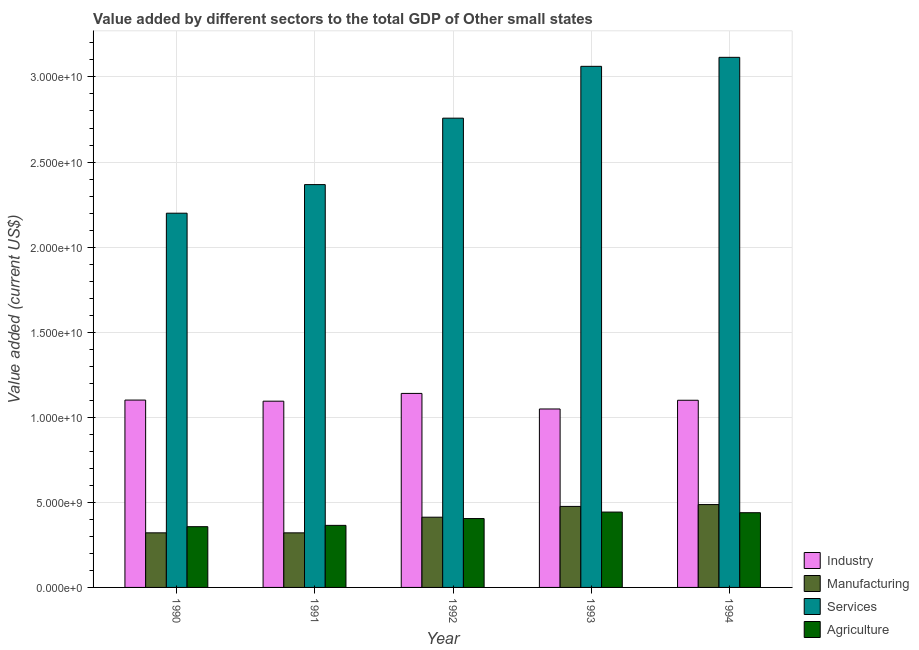How many different coloured bars are there?
Make the answer very short. 4. Are the number of bars on each tick of the X-axis equal?
Provide a succinct answer. Yes. How many bars are there on the 1st tick from the right?
Keep it short and to the point. 4. What is the label of the 4th group of bars from the left?
Provide a short and direct response. 1993. What is the value added by industrial sector in 1993?
Your answer should be compact. 1.05e+1. Across all years, what is the maximum value added by manufacturing sector?
Offer a very short reply. 4.87e+09. Across all years, what is the minimum value added by industrial sector?
Offer a terse response. 1.05e+1. In which year was the value added by industrial sector minimum?
Offer a very short reply. 1993. What is the total value added by agricultural sector in the graph?
Offer a terse response. 2.01e+1. What is the difference between the value added by agricultural sector in 1990 and that in 1991?
Your answer should be compact. -7.65e+07. What is the difference between the value added by services sector in 1992 and the value added by agricultural sector in 1993?
Ensure brevity in your answer.  -3.05e+09. What is the average value added by manufacturing sector per year?
Your answer should be compact. 4.03e+09. In the year 1993, what is the difference between the value added by manufacturing sector and value added by services sector?
Provide a short and direct response. 0. What is the ratio of the value added by agricultural sector in 1993 to that in 1994?
Ensure brevity in your answer.  1.01. Is the difference between the value added by agricultural sector in 1990 and 1991 greater than the difference between the value added by industrial sector in 1990 and 1991?
Offer a terse response. No. What is the difference between the highest and the second highest value added by services sector?
Provide a succinct answer. 5.29e+08. What is the difference between the highest and the lowest value added by agricultural sector?
Give a very brief answer. 8.58e+08. In how many years, is the value added by industrial sector greater than the average value added by industrial sector taken over all years?
Make the answer very short. 3. Is the sum of the value added by agricultural sector in 1990 and 1993 greater than the maximum value added by manufacturing sector across all years?
Keep it short and to the point. Yes. Is it the case that in every year, the sum of the value added by manufacturing sector and value added by agricultural sector is greater than the sum of value added by industrial sector and value added by services sector?
Your answer should be very brief. No. What does the 4th bar from the left in 1990 represents?
Keep it short and to the point. Agriculture. What does the 1st bar from the right in 1994 represents?
Make the answer very short. Agriculture. Are all the bars in the graph horizontal?
Make the answer very short. No. How are the legend labels stacked?
Your answer should be compact. Vertical. What is the title of the graph?
Your answer should be compact. Value added by different sectors to the total GDP of Other small states. What is the label or title of the Y-axis?
Make the answer very short. Value added (current US$). What is the Value added (current US$) of Industry in 1990?
Your response must be concise. 1.10e+1. What is the Value added (current US$) in Manufacturing in 1990?
Give a very brief answer. 3.21e+09. What is the Value added (current US$) of Services in 1990?
Ensure brevity in your answer.  2.20e+1. What is the Value added (current US$) in Agriculture in 1990?
Your answer should be very brief. 3.57e+09. What is the Value added (current US$) of Industry in 1991?
Provide a succinct answer. 1.09e+1. What is the Value added (current US$) of Manufacturing in 1991?
Offer a terse response. 3.21e+09. What is the Value added (current US$) in Services in 1991?
Ensure brevity in your answer.  2.37e+1. What is the Value added (current US$) in Agriculture in 1991?
Your answer should be compact. 3.65e+09. What is the Value added (current US$) in Industry in 1992?
Your response must be concise. 1.14e+1. What is the Value added (current US$) of Manufacturing in 1992?
Keep it short and to the point. 4.13e+09. What is the Value added (current US$) in Services in 1992?
Your answer should be very brief. 2.76e+1. What is the Value added (current US$) of Agriculture in 1992?
Provide a short and direct response. 4.05e+09. What is the Value added (current US$) of Industry in 1993?
Your answer should be compact. 1.05e+1. What is the Value added (current US$) of Manufacturing in 1993?
Provide a short and direct response. 4.76e+09. What is the Value added (current US$) of Services in 1993?
Ensure brevity in your answer.  3.06e+1. What is the Value added (current US$) in Agriculture in 1993?
Your answer should be very brief. 4.43e+09. What is the Value added (current US$) in Industry in 1994?
Make the answer very short. 1.10e+1. What is the Value added (current US$) in Manufacturing in 1994?
Keep it short and to the point. 4.87e+09. What is the Value added (current US$) in Services in 1994?
Your answer should be compact. 3.12e+1. What is the Value added (current US$) in Agriculture in 1994?
Give a very brief answer. 4.39e+09. Across all years, what is the maximum Value added (current US$) of Industry?
Your answer should be compact. 1.14e+1. Across all years, what is the maximum Value added (current US$) of Manufacturing?
Keep it short and to the point. 4.87e+09. Across all years, what is the maximum Value added (current US$) in Services?
Your answer should be very brief. 3.12e+1. Across all years, what is the maximum Value added (current US$) in Agriculture?
Keep it short and to the point. 4.43e+09. Across all years, what is the minimum Value added (current US$) of Industry?
Keep it short and to the point. 1.05e+1. Across all years, what is the minimum Value added (current US$) in Manufacturing?
Give a very brief answer. 3.21e+09. Across all years, what is the minimum Value added (current US$) of Services?
Offer a very short reply. 2.20e+1. Across all years, what is the minimum Value added (current US$) of Agriculture?
Give a very brief answer. 3.57e+09. What is the total Value added (current US$) of Industry in the graph?
Offer a very short reply. 5.48e+1. What is the total Value added (current US$) in Manufacturing in the graph?
Offer a very short reply. 2.02e+1. What is the total Value added (current US$) in Services in the graph?
Give a very brief answer. 1.35e+11. What is the total Value added (current US$) of Agriculture in the graph?
Keep it short and to the point. 2.01e+1. What is the difference between the Value added (current US$) in Industry in 1990 and that in 1991?
Give a very brief answer. 6.57e+07. What is the difference between the Value added (current US$) of Manufacturing in 1990 and that in 1991?
Offer a very short reply. 3.41e+05. What is the difference between the Value added (current US$) of Services in 1990 and that in 1991?
Provide a short and direct response. -1.68e+09. What is the difference between the Value added (current US$) of Agriculture in 1990 and that in 1991?
Ensure brevity in your answer.  -7.65e+07. What is the difference between the Value added (current US$) of Industry in 1990 and that in 1992?
Your response must be concise. -3.91e+08. What is the difference between the Value added (current US$) of Manufacturing in 1990 and that in 1992?
Your answer should be very brief. -9.19e+08. What is the difference between the Value added (current US$) of Services in 1990 and that in 1992?
Your answer should be compact. -5.58e+09. What is the difference between the Value added (current US$) of Agriculture in 1990 and that in 1992?
Ensure brevity in your answer.  -4.77e+08. What is the difference between the Value added (current US$) in Industry in 1990 and that in 1993?
Make the answer very short. 5.24e+08. What is the difference between the Value added (current US$) of Manufacturing in 1990 and that in 1993?
Ensure brevity in your answer.  -1.55e+09. What is the difference between the Value added (current US$) in Services in 1990 and that in 1993?
Give a very brief answer. -8.63e+09. What is the difference between the Value added (current US$) of Agriculture in 1990 and that in 1993?
Offer a very short reply. -8.58e+08. What is the difference between the Value added (current US$) in Industry in 1990 and that in 1994?
Make the answer very short. 1.17e+07. What is the difference between the Value added (current US$) in Manufacturing in 1990 and that in 1994?
Your answer should be very brief. -1.66e+09. What is the difference between the Value added (current US$) in Services in 1990 and that in 1994?
Your answer should be compact. -9.16e+09. What is the difference between the Value added (current US$) of Agriculture in 1990 and that in 1994?
Offer a terse response. -8.20e+08. What is the difference between the Value added (current US$) of Industry in 1991 and that in 1992?
Offer a very short reply. -4.57e+08. What is the difference between the Value added (current US$) in Manufacturing in 1991 and that in 1992?
Offer a very short reply. -9.19e+08. What is the difference between the Value added (current US$) in Services in 1991 and that in 1992?
Your answer should be very brief. -3.90e+09. What is the difference between the Value added (current US$) of Agriculture in 1991 and that in 1992?
Your response must be concise. -4.00e+08. What is the difference between the Value added (current US$) in Industry in 1991 and that in 1993?
Your answer should be very brief. 4.58e+08. What is the difference between the Value added (current US$) in Manufacturing in 1991 and that in 1993?
Provide a short and direct response. -1.55e+09. What is the difference between the Value added (current US$) of Services in 1991 and that in 1993?
Ensure brevity in your answer.  -6.95e+09. What is the difference between the Value added (current US$) of Agriculture in 1991 and that in 1993?
Your response must be concise. -7.81e+08. What is the difference between the Value added (current US$) of Industry in 1991 and that in 1994?
Keep it short and to the point. -5.40e+07. What is the difference between the Value added (current US$) in Manufacturing in 1991 and that in 1994?
Make the answer very short. -1.66e+09. What is the difference between the Value added (current US$) in Services in 1991 and that in 1994?
Your response must be concise. -7.48e+09. What is the difference between the Value added (current US$) of Agriculture in 1991 and that in 1994?
Give a very brief answer. -7.44e+08. What is the difference between the Value added (current US$) in Industry in 1992 and that in 1993?
Ensure brevity in your answer.  9.15e+08. What is the difference between the Value added (current US$) in Manufacturing in 1992 and that in 1993?
Your response must be concise. -6.34e+08. What is the difference between the Value added (current US$) in Services in 1992 and that in 1993?
Your response must be concise. -3.05e+09. What is the difference between the Value added (current US$) in Agriculture in 1992 and that in 1993?
Offer a terse response. -3.81e+08. What is the difference between the Value added (current US$) of Industry in 1992 and that in 1994?
Give a very brief answer. 4.03e+08. What is the difference between the Value added (current US$) in Manufacturing in 1992 and that in 1994?
Ensure brevity in your answer.  -7.43e+08. What is the difference between the Value added (current US$) of Services in 1992 and that in 1994?
Ensure brevity in your answer.  -3.58e+09. What is the difference between the Value added (current US$) of Agriculture in 1992 and that in 1994?
Make the answer very short. -3.44e+08. What is the difference between the Value added (current US$) of Industry in 1993 and that in 1994?
Offer a terse response. -5.12e+08. What is the difference between the Value added (current US$) in Manufacturing in 1993 and that in 1994?
Your answer should be compact. -1.09e+08. What is the difference between the Value added (current US$) of Services in 1993 and that in 1994?
Your response must be concise. -5.29e+08. What is the difference between the Value added (current US$) in Agriculture in 1993 and that in 1994?
Provide a succinct answer. 3.76e+07. What is the difference between the Value added (current US$) in Industry in 1990 and the Value added (current US$) in Manufacturing in 1991?
Your answer should be compact. 7.80e+09. What is the difference between the Value added (current US$) in Industry in 1990 and the Value added (current US$) in Services in 1991?
Keep it short and to the point. -1.27e+1. What is the difference between the Value added (current US$) of Industry in 1990 and the Value added (current US$) of Agriculture in 1991?
Your answer should be compact. 7.36e+09. What is the difference between the Value added (current US$) of Manufacturing in 1990 and the Value added (current US$) of Services in 1991?
Offer a terse response. -2.05e+1. What is the difference between the Value added (current US$) in Manufacturing in 1990 and the Value added (current US$) in Agriculture in 1991?
Keep it short and to the point. -4.39e+08. What is the difference between the Value added (current US$) of Services in 1990 and the Value added (current US$) of Agriculture in 1991?
Your response must be concise. 1.83e+1. What is the difference between the Value added (current US$) in Industry in 1990 and the Value added (current US$) in Manufacturing in 1992?
Give a very brief answer. 6.88e+09. What is the difference between the Value added (current US$) of Industry in 1990 and the Value added (current US$) of Services in 1992?
Provide a succinct answer. -1.66e+1. What is the difference between the Value added (current US$) of Industry in 1990 and the Value added (current US$) of Agriculture in 1992?
Make the answer very short. 6.96e+09. What is the difference between the Value added (current US$) of Manufacturing in 1990 and the Value added (current US$) of Services in 1992?
Provide a succinct answer. -2.44e+1. What is the difference between the Value added (current US$) in Manufacturing in 1990 and the Value added (current US$) in Agriculture in 1992?
Make the answer very short. -8.39e+08. What is the difference between the Value added (current US$) of Services in 1990 and the Value added (current US$) of Agriculture in 1992?
Offer a terse response. 1.79e+1. What is the difference between the Value added (current US$) of Industry in 1990 and the Value added (current US$) of Manufacturing in 1993?
Your response must be concise. 6.25e+09. What is the difference between the Value added (current US$) of Industry in 1990 and the Value added (current US$) of Services in 1993?
Keep it short and to the point. -1.96e+1. What is the difference between the Value added (current US$) of Industry in 1990 and the Value added (current US$) of Agriculture in 1993?
Provide a succinct answer. 6.58e+09. What is the difference between the Value added (current US$) of Manufacturing in 1990 and the Value added (current US$) of Services in 1993?
Provide a succinct answer. -2.74e+1. What is the difference between the Value added (current US$) of Manufacturing in 1990 and the Value added (current US$) of Agriculture in 1993?
Your response must be concise. -1.22e+09. What is the difference between the Value added (current US$) in Services in 1990 and the Value added (current US$) in Agriculture in 1993?
Keep it short and to the point. 1.76e+1. What is the difference between the Value added (current US$) in Industry in 1990 and the Value added (current US$) in Manufacturing in 1994?
Your response must be concise. 6.14e+09. What is the difference between the Value added (current US$) of Industry in 1990 and the Value added (current US$) of Services in 1994?
Offer a terse response. -2.01e+1. What is the difference between the Value added (current US$) in Industry in 1990 and the Value added (current US$) in Agriculture in 1994?
Provide a short and direct response. 6.62e+09. What is the difference between the Value added (current US$) of Manufacturing in 1990 and the Value added (current US$) of Services in 1994?
Provide a short and direct response. -2.79e+1. What is the difference between the Value added (current US$) in Manufacturing in 1990 and the Value added (current US$) in Agriculture in 1994?
Keep it short and to the point. -1.18e+09. What is the difference between the Value added (current US$) of Services in 1990 and the Value added (current US$) of Agriculture in 1994?
Your response must be concise. 1.76e+1. What is the difference between the Value added (current US$) in Industry in 1991 and the Value added (current US$) in Manufacturing in 1992?
Give a very brief answer. 6.82e+09. What is the difference between the Value added (current US$) of Industry in 1991 and the Value added (current US$) of Services in 1992?
Offer a very short reply. -1.66e+1. What is the difference between the Value added (current US$) of Industry in 1991 and the Value added (current US$) of Agriculture in 1992?
Give a very brief answer. 6.90e+09. What is the difference between the Value added (current US$) of Manufacturing in 1991 and the Value added (current US$) of Services in 1992?
Give a very brief answer. -2.44e+1. What is the difference between the Value added (current US$) in Manufacturing in 1991 and the Value added (current US$) in Agriculture in 1992?
Your answer should be very brief. -8.39e+08. What is the difference between the Value added (current US$) in Services in 1991 and the Value added (current US$) in Agriculture in 1992?
Ensure brevity in your answer.  1.96e+1. What is the difference between the Value added (current US$) in Industry in 1991 and the Value added (current US$) in Manufacturing in 1993?
Your response must be concise. 6.18e+09. What is the difference between the Value added (current US$) in Industry in 1991 and the Value added (current US$) in Services in 1993?
Make the answer very short. -1.97e+1. What is the difference between the Value added (current US$) of Industry in 1991 and the Value added (current US$) of Agriculture in 1993?
Provide a short and direct response. 6.52e+09. What is the difference between the Value added (current US$) of Manufacturing in 1991 and the Value added (current US$) of Services in 1993?
Ensure brevity in your answer.  -2.74e+1. What is the difference between the Value added (current US$) in Manufacturing in 1991 and the Value added (current US$) in Agriculture in 1993?
Your answer should be very brief. -1.22e+09. What is the difference between the Value added (current US$) of Services in 1991 and the Value added (current US$) of Agriculture in 1993?
Your answer should be compact. 1.92e+1. What is the difference between the Value added (current US$) of Industry in 1991 and the Value added (current US$) of Manufacturing in 1994?
Provide a succinct answer. 6.08e+09. What is the difference between the Value added (current US$) of Industry in 1991 and the Value added (current US$) of Services in 1994?
Ensure brevity in your answer.  -2.02e+1. What is the difference between the Value added (current US$) in Industry in 1991 and the Value added (current US$) in Agriculture in 1994?
Your answer should be very brief. 6.55e+09. What is the difference between the Value added (current US$) in Manufacturing in 1991 and the Value added (current US$) in Services in 1994?
Offer a very short reply. -2.79e+1. What is the difference between the Value added (current US$) of Manufacturing in 1991 and the Value added (current US$) of Agriculture in 1994?
Your response must be concise. -1.18e+09. What is the difference between the Value added (current US$) of Services in 1991 and the Value added (current US$) of Agriculture in 1994?
Provide a succinct answer. 1.93e+1. What is the difference between the Value added (current US$) in Industry in 1992 and the Value added (current US$) in Manufacturing in 1993?
Your response must be concise. 6.64e+09. What is the difference between the Value added (current US$) in Industry in 1992 and the Value added (current US$) in Services in 1993?
Make the answer very short. -1.92e+1. What is the difference between the Value added (current US$) of Industry in 1992 and the Value added (current US$) of Agriculture in 1993?
Your answer should be very brief. 6.97e+09. What is the difference between the Value added (current US$) of Manufacturing in 1992 and the Value added (current US$) of Services in 1993?
Provide a short and direct response. -2.65e+1. What is the difference between the Value added (current US$) in Manufacturing in 1992 and the Value added (current US$) in Agriculture in 1993?
Offer a very short reply. -3.01e+08. What is the difference between the Value added (current US$) of Services in 1992 and the Value added (current US$) of Agriculture in 1993?
Your answer should be compact. 2.31e+1. What is the difference between the Value added (current US$) of Industry in 1992 and the Value added (current US$) of Manufacturing in 1994?
Make the answer very short. 6.53e+09. What is the difference between the Value added (current US$) in Industry in 1992 and the Value added (current US$) in Services in 1994?
Give a very brief answer. -1.98e+1. What is the difference between the Value added (current US$) in Industry in 1992 and the Value added (current US$) in Agriculture in 1994?
Offer a very short reply. 7.01e+09. What is the difference between the Value added (current US$) of Manufacturing in 1992 and the Value added (current US$) of Services in 1994?
Your response must be concise. -2.70e+1. What is the difference between the Value added (current US$) of Manufacturing in 1992 and the Value added (current US$) of Agriculture in 1994?
Your answer should be compact. -2.64e+08. What is the difference between the Value added (current US$) in Services in 1992 and the Value added (current US$) in Agriculture in 1994?
Give a very brief answer. 2.32e+1. What is the difference between the Value added (current US$) of Industry in 1993 and the Value added (current US$) of Manufacturing in 1994?
Provide a short and direct response. 5.62e+09. What is the difference between the Value added (current US$) of Industry in 1993 and the Value added (current US$) of Services in 1994?
Ensure brevity in your answer.  -2.07e+1. What is the difference between the Value added (current US$) in Industry in 1993 and the Value added (current US$) in Agriculture in 1994?
Your response must be concise. 6.10e+09. What is the difference between the Value added (current US$) of Manufacturing in 1993 and the Value added (current US$) of Services in 1994?
Make the answer very short. -2.64e+1. What is the difference between the Value added (current US$) in Manufacturing in 1993 and the Value added (current US$) in Agriculture in 1994?
Keep it short and to the point. 3.70e+08. What is the difference between the Value added (current US$) of Services in 1993 and the Value added (current US$) of Agriculture in 1994?
Give a very brief answer. 2.62e+1. What is the average Value added (current US$) of Industry per year?
Offer a terse response. 1.10e+1. What is the average Value added (current US$) of Manufacturing per year?
Your response must be concise. 4.03e+09. What is the average Value added (current US$) in Services per year?
Give a very brief answer. 2.70e+1. What is the average Value added (current US$) of Agriculture per year?
Provide a succinct answer. 4.02e+09. In the year 1990, what is the difference between the Value added (current US$) of Industry and Value added (current US$) of Manufacturing?
Your answer should be very brief. 7.80e+09. In the year 1990, what is the difference between the Value added (current US$) in Industry and Value added (current US$) in Services?
Provide a succinct answer. -1.10e+1. In the year 1990, what is the difference between the Value added (current US$) of Industry and Value added (current US$) of Agriculture?
Provide a short and direct response. 7.44e+09. In the year 1990, what is the difference between the Value added (current US$) of Manufacturing and Value added (current US$) of Services?
Provide a succinct answer. -1.88e+1. In the year 1990, what is the difference between the Value added (current US$) in Manufacturing and Value added (current US$) in Agriculture?
Your response must be concise. -3.62e+08. In the year 1990, what is the difference between the Value added (current US$) in Services and Value added (current US$) in Agriculture?
Keep it short and to the point. 1.84e+1. In the year 1991, what is the difference between the Value added (current US$) of Industry and Value added (current US$) of Manufacturing?
Offer a terse response. 7.74e+09. In the year 1991, what is the difference between the Value added (current US$) in Industry and Value added (current US$) in Services?
Ensure brevity in your answer.  -1.27e+1. In the year 1991, what is the difference between the Value added (current US$) in Industry and Value added (current US$) in Agriculture?
Provide a short and direct response. 7.30e+09. In the year 1991, what is the difference between the Value added (current US$) of Manufacturing and Value added (current US$) of Services?
Provide a succinct answer. -2.05e+1. In the year 1991, what is the difference between the Value added (current US$) in Manufacturing and Value added (current US$) in Agriculture?
Provide a short and direct response. -4.39e+08. In the year 1991, what is the difference between the Value added (current US$) in Services and Value added (current US$) in Agriculture?
Offer a very short reply. 2.00e+1. In the year 1992, what is the difference between the Value added (current US$) in Industry and Value added (current US$) in Manufacturing?
Keep it short and to the point. 7.28e+09. In the year 1992, what is the difference between the Value added (current US$) in Industry and Value added (current US$) in Services?
Give a very brief answer. -1.62e+1. In the year 1992, what is the difference between the Value added (current US$) of Industry and Value added (current US$) of Agriculture?
Offer a terse response. 7.36e+09. In the year 1992, what is the difference between the Value added (current US$) of Manufacturing and Value added (current US$) of Services?
Your answer should be compact. -2.35e+1. In the year 1992, what is the difference between the Value added (current US$) of Manufacturing and Value added (current US$) of Agriculture?
Offer a very short reply. 7.99e+07. In the year 1992, what is the difference between the Value added (current US$) of Services and Value added (current US$) of Agriculture?
Give a very brief answer. 2.35e+1. In the year 1993, what is the difference between the Value added (current US$) of Industry and Value added (current US$) of Manufacturing?
Make the answer very short. 5.73e+09. In the year 1993, what is the difference between the Value added (current US$) of Industry and Value added (current US$) of Services?
Give a very brief answer. -2.01e+1. In the year 1993, what is the difference between the Value added (current US$) in Industry and Value added (current US$) in Agriculture?
Provide a short and direct response. 6.06e+09. In the year 1993, what is the difference between the Value added (current US$) of Manufacturing and Value added (current US$) of Services?
Make the answer very short. -2.59e+1. In the year 1993, what is the difference between the Value added (current US$) in Manufacturing and Value added (current US$) in Agriculture?
Offer a terse response. 3.33e+08. In the year 1993, what is the difference between the Value added (current US$) of Services and Value added (current US$) of Agriculture?
Your answer should be compact. 2.62e+1. In the year 1994, what is the difference between the Value added (current US$) in Industry and Value added (current US$) in Manufacturing?
Offer a very short reply. 6.13e+09. In the year 1994, what is the difference between the Value added (current US$) in Industry and Value added (current US$) in Services?
Keep it short and to the point. -2.02e+1. In the year 1994, what is the difference between the Value added (current US$) of Industry and Value added (current US$) of Agriculture?
Ensure brevity in your answer.  6.61e+09. In the year 1994, what is the difference between the Value added (current US$) in Manufacturing and Value added (current US$) in Services?
Your answer should be compact. -2.63e+1. In the year 1994, what is the difference between the Value added (current US$) in Manufacturing and Value added (current US$) in Agriculture?
Offer a very short reply. 4.79e+08. In the year 1994, what is the difference between the Value added (current US$) of Services and Value added (current US$) of Agriculture?
Offer a very short reply. 2.68e+1. What is the ratio of the Value added (current US$) of Industry in 1990 to that in 1991?
Offer a terse response. 1.01. What is the ratio of the Value added (current US$) in Services in 1990 to that in 1991?
Ensure brevity in your answer.  0.93. What is the ratio of the Value added (current US$) in Industry in 1990 to that in 1992?
Provide a short and direct response. 0.97. What is the ratio of the Value added (current US$) in Manufacturing in 1990 to that in 1992?
Provide a succinct answer. 0.78. What is the ratio of the Value added (current US$) of Services in 1990 to that in 1992?
Keep it short and to the point. 0.8. What is the ratio of the Value added (current US$) of Agriculture in 1990 to that in 1992?
Provide a succinct answer. 0.88. What is the ratio of the Value added (current US$) in Industry in 1990 to that in 1993?
Offer a terse response. 1.05. What is the ratio of the Value added (current US$) in Manufacturing in 1990 to that in 1993?
Offer a terse response. 0.67. What is the ratio of the Value added (current US$) in Services in 1990 to that in 1993?
Make the answer very short. 0.72. What is the ratio of the Value added (current US$) in Agriculture in 1990 to that in 1993?
Your answer should be very brief. 0.81. What is the ratio of the Value added (current US$) of Manufacturing in 1990 to that in 1994?
Offer a terse response. 0.66. What is the ratio of the Value added (current US$) of Services in 1990 to that in 1994?
Your answer should be compact. 0.71. What is the ratio of the Value added (current US$) in Agriculture in 1990 to that in 1994?
Provide a short and direct response. 0.81. What is the ratio of the Value added (current US$) in Industry in 1991 to that in 1992?
Your answer should be compact. 0.96. What is the ratio of the Value added (current US$) in Manufacturing in 1991 to that in 1992?
Your response must be concise. 0.78. What is the ratio of the Value added (current US$) in Services in 1991 to that in 1992?
Your answer should be compact. 0.86. What is the ratio of the Value added (current US$) of Agriculture in 1991 to that in 1992?
Ensure brevity in your answer.  0.9. What is the ratio of the Value added (current US$) in Industry in 1991 to that in 1993?
Make the answer very short. 1.04. What is the ratio of the Value added (current US$) of Manufacturing in 1991 to that in 1993?
Your answer should be very brief. 0.67. What is the ratio of the Value added (current US$) of Services in 1991 to that in 1993?
Provide a succinct answer. 0.77. What is the ratio of the Value added (current US$) in Agriculture in 1991 to that in 1993?
Your response must be concise. 0.82. What is the ratio of the Value added (current US$) of Industry in 1991 to that in 1994?
Offer a terse response. 1. What is the ratio of the Value added (current US$) in Manufacturing in 1991 to that in 1994?
Your answer should be compact. 0.66. What is the ratio of the Value added (current US$) of Services in 1991 to that in 1994?
Your response must be concise. 0.76. What is the ratio of the Value added (current US$) in Agriculture in 1991 to that in 1994?
Keep it short and to the point. 0.83. What is the ratio of the Value added (current US$) in Industry in 1992 to that in 1993?
Make the answer very short. 1.09. What is the ratio of the Value added (current US$) in Manufacturing in 1992 to that in 1993?
Make the answer very short. 0.87. What is the ratio of the Value added (current US$) in Services in 1992 to that in 1993?
Provide a succinct answer. 0.9. What is the ratio of the Value added (current US$) of Agriculture in 1992 to that in 1993?
Ensure brevity in your answer.  0.91. What is the ratio of the Value added (current US$) in Industry in 1992 to that in 1994?
Provide a short and direct response. 1.04. What is the ratio of the Value added (current US$) in Manufacturing in 1992 to that in 1994?
Give a very brief answer. 0.85. What is the ratio of the Value added (current US$) of Services in 1992 to that in 1994?
Offer a terse response. 0.89. What is the ratio of the Value added (current US$) in Agriculture in 1992 to that in 1994?
Your answer should be compact. 0.92. What is the ratio of the Value added (current US$) of Industry in 1993 to that in 1994?
Provide a succinct answer. 0.95. What is the ratio of the Value added (current US$) in Manufacturing in 1993 to that in 1994?
Provide a succinct answer. 0.98. What is the ratio of the Value added (current US$) of Agriculture in 1993 to that in 1994?
Ensure brevity in your answer.  1.01. What is the difference between the highest and the second highest Value added (current US$) of Industry?
Make the answer very short. 3.91e+08. What is the difference between the highest and the second highest Value added (current US$) in Manufacturing?
Your answer should be compact. 1.09e+08. What is the difference between the highest and the second highest Value added (current US$) in Services?
Ensure brevity in your answer.  5.29e+08. What is the difference between the highest and the second highest Value added (current US$) of Agriculture?
Keep it short and to the point. 3.76e+07. What is the difference between the highest and the lowest Value added (current US$) in Industry?
Your answer should be compact. 9.15e+08. What is the difference between the highest and the lowest Value added (current US$) in Manufacturing?
Offer a very short reply. 1.66e+09. What is the difference between the highest and the lowest Value added (current US$) in Services?
Give a very brief answer. 9.16e+09. What is the difference between the highest and the lowest Value added (current US$) of Agriculture?
Your answer should be very brief. 8.58e+08. 